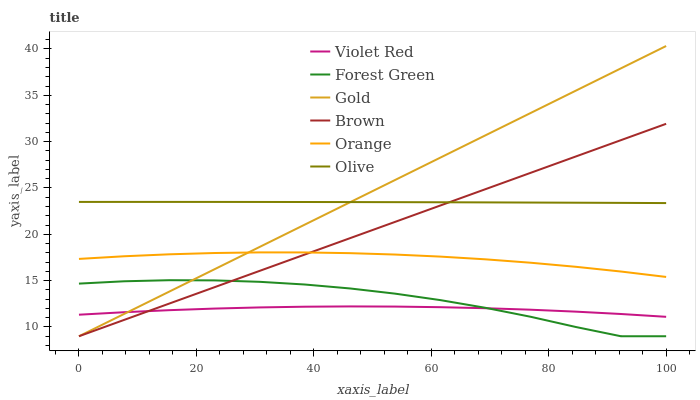Does Violet Red have the minimum area under the curve?
Answer yes or no. Yes. Does Gold have the maximum area under the curve?
Answer yes or no. Yes. Does Gold have the minimum area under the curve?
Answer yes or no. No. Does Violet Red have the maximum area under the curve?
Answer yes or no. No. Is Brown the smoothest?
Answer yes or no. Yes. Is Forest Green the roughest?
Answer yes or no. Yes. Is Violet Red the smoothest?
Answer yes or no. No. Is Violet Red the roughest?
Answer yes or no. No. Does Brown have the lowest value?
Answer yes or no. Yes. Does Violet Red have the lowest value?
Answer yes or no. No. Does Gold have the highest value?
Answer yes or no. Yes. Does Violet Red have the highest value?
Answer yes or no. No. Is Violet Red less than Orange?
Answer yes or no. Yes. Is Orange greater than Forest Green?
Answer yes or no. Yes. Does Brown intersect Violet Red?
Answer yes or no. Yes. Is Brown less than Violet Red?
Answer yes or no. No. Is Brown greater than Violet Red?
Answer yes or no. No. Does Violet Red intersect Orange?
Answer yes or no. No. 